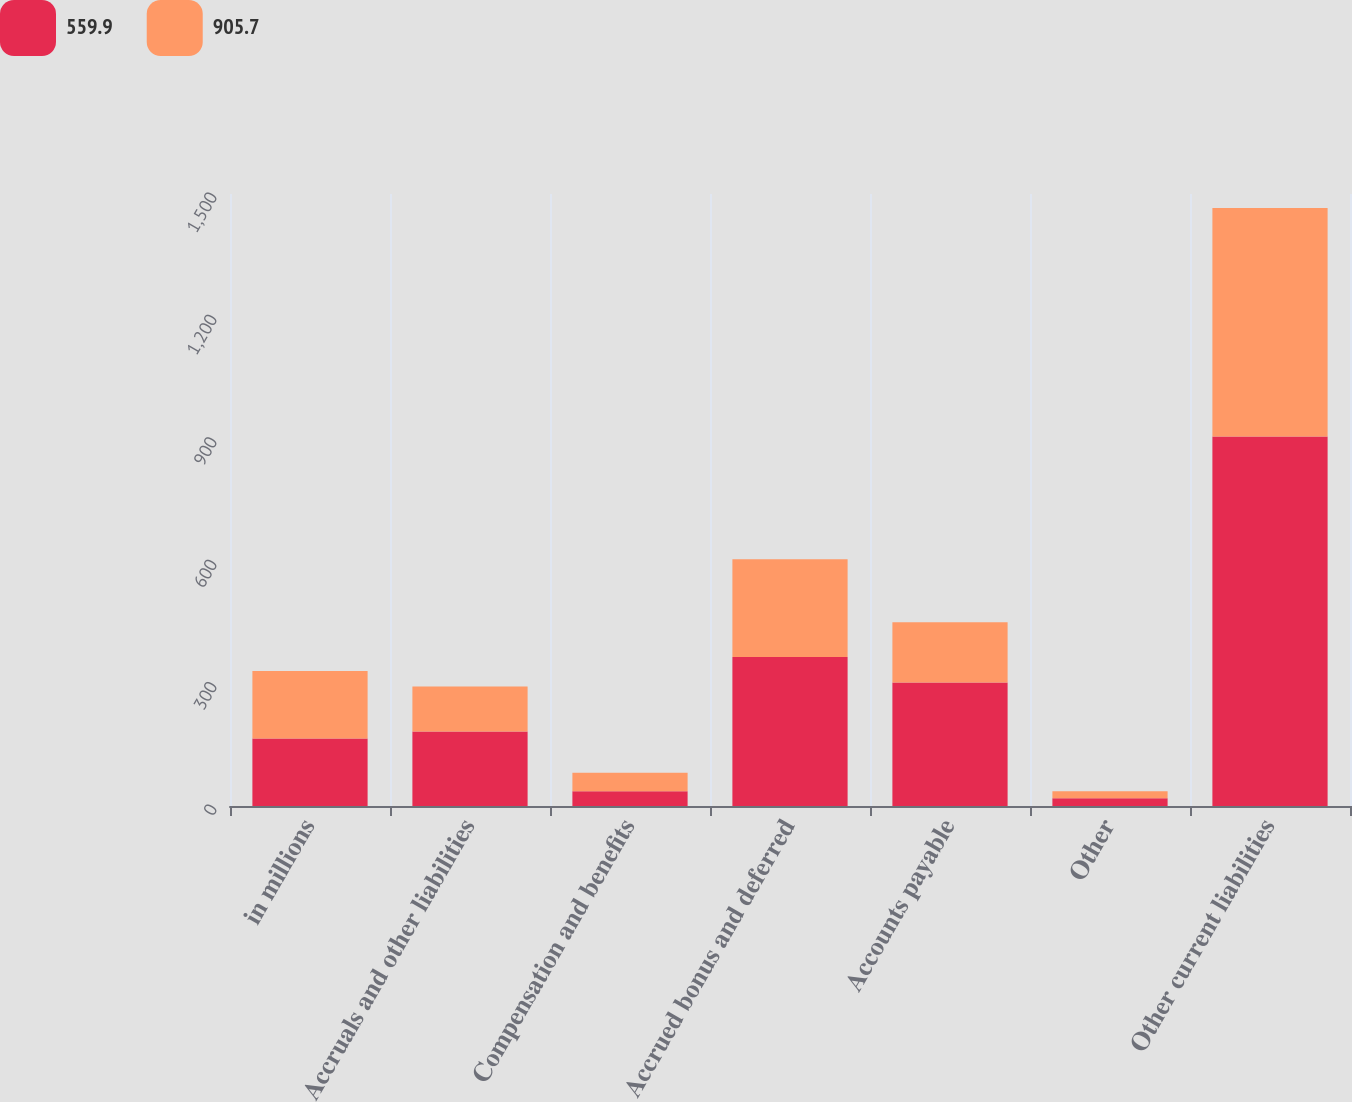Convert chart. <chart><loc_0><loc_0><loc_500><loc_500><stacked_bar_chart><ecel><fcel>in millions<fcel>Accruals and other liabilities<fcel>Compensation and benefits<fcel>Accrued bonus and deferred<fcel>Accounts payable<fcel>Other<fcel>Other current liabilities<nl><fcel>559.9<fcel>165.3<fcel>182.5<fcel>36.4<fcel>365.3<fcel>302.5<fcel>19<fcel>905.7<nl><fcel>905.7<fcel>165.3<fcel>110.4<fcel>45.1<fcel>239.2<fcel>148.1<fcel>17.1<fcel>559.9<nl></chart> 